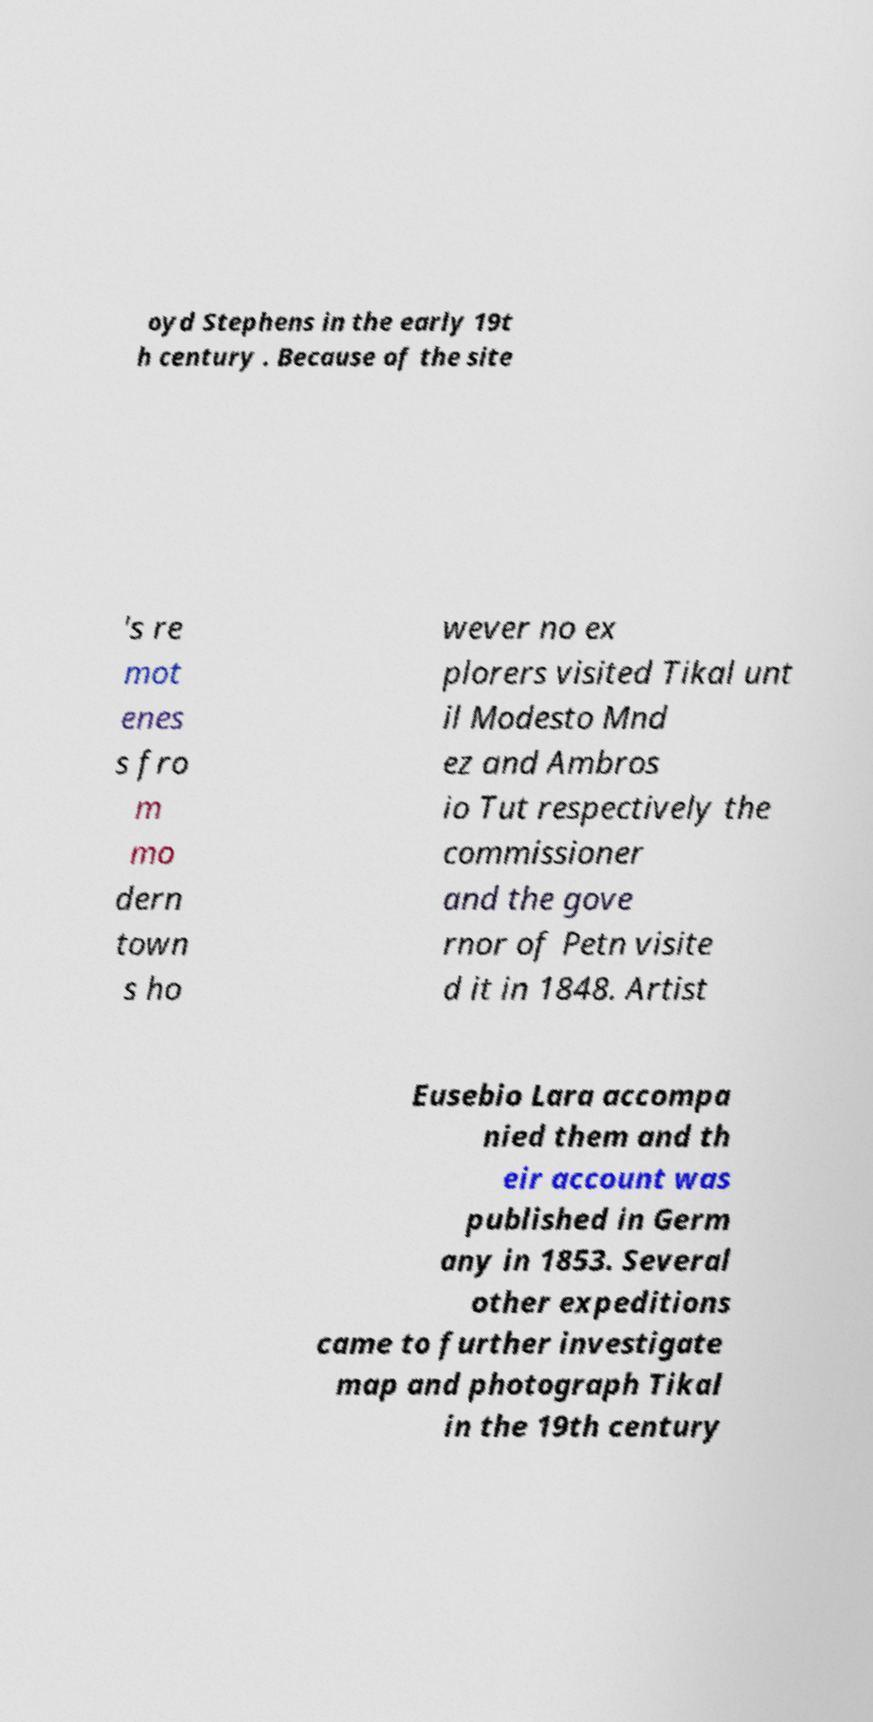I need the written content from this picture converted into text. Can you do that? oyd Stephens in the early 19t h century . Because of the site 's re mot enes s fro m mo dern town s ho wever no ex plorers visited Tikal unt il Modesto Mnd ez and Ambros io Tut respectively the commissioner and the gove rnor of Petn visite d it in 1848. Artist Eusebio Lara accompa nied them and th eir account was published in Germ any in 1853. Several other expeditions came to further investigate map and photograph Tikal in the 19th century 